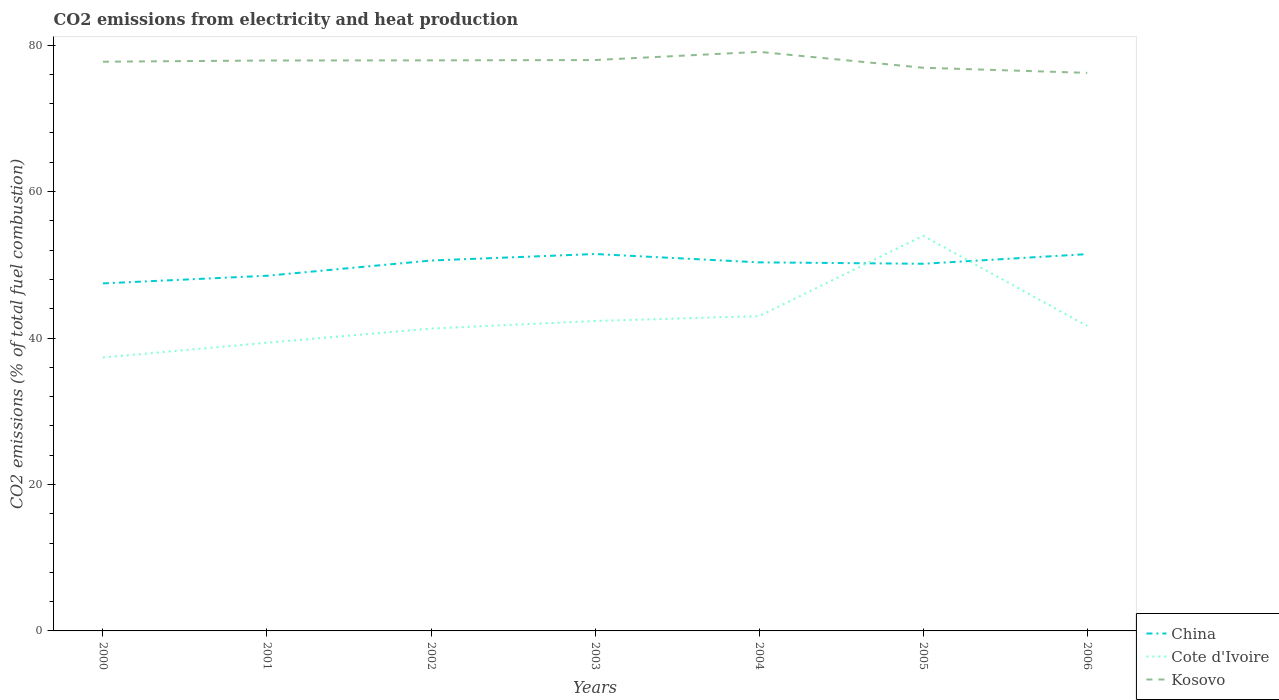Does the line corresponding to Kosovo intersect with the line corresponding to China?
Keep it short and to the point. No. Across all years, what is the maximum amount of CO2 emitted in Kosovo?
Your response must be concise. 76.21. What is the total amount of CO2 emitted in China in the graph?
Make the answer very short. -1.64. What is the difference between the highest and the second highest amount of CO2 emitted in Kosovo?
Your response must be concise. 2.87. What is the difference between the highest and the lowest amount of CO2 emitted in Cote d'Ivoire?
Offer a terse response. 2. How many lines are there?
Offer a very short reply. 3. What is the difference between two consecutive major ticks on the Y-axis?
Provide a succinct answer. 20. Does the graph contain any zero values?
Your answer should be compact. No. Does the graph contain grids?
Your response must be concise. No. How many legend labels are there?
Keep it short and to the point. 3. How are the legend labels stacked?
Ensure brevity in your answer.  Vertical. What is the title of the graph?
Your answer should be compact. CO2 emissions from electricity and heat production. What is the label or title of the Y-axis?
Keep it short and to the point. CO2 emissions (% of total fuel combustion). What is the CO2 emissions (% of total fuel combustion) in China in 2000?
Keep it short and to the point. 47.46. What is the CO2 emissions (% of total fuel combustion) of Cote d'Ivoire in 2000?
Give a very brief answer. 37.34. What is the CO2 emissions (% of total fuel combustion) of Kosovo in 2000?
Offer a terse response. 77.73. What is the CO2 emissions (% of total fuel combustion) of China in 2001?
Your answer should be very brief. 48.5. What is the CO2 emissions (% of total fuel combustion) in Cote d'Ivoire in 2001?
Your answer should be very brief. 39.36. What is the CO2 emissions (% of total fuel combustion) in Kosovo in 2001?
Keep it short and to the point. 77.9. What is the CO2 emissions (% of total fuel combustion) in China in 2002?
Your answer should be very brief. 50.58. What is the CO2 emissions (% of total fuel combustion) in Cote d'Ivoire in 2002?
Provide a succinct answer. 41.29. What is the CO2 emissions (% of total fuel combustion) in Kosovo in 2002?
Keep it short and to the point. 77.92. What is the CO2 emissions (% of total fuel combustion) of China in 2003?
Ensure brevity in your answer.  51.47. What is the CO2 emissions (% of total fuel combustion) in Cote d'Ivoire in 2003?
Keep it short and to the point. 42.33. What is the CO2 emissions (% of total fuel combustion) of Kosovo in 2003?
Your answer should be compact. 77.96. What is the CO2 emissions (% of total fuel combustion) in China in 2004?
Offer a terse response. 50.33. What is the CO2 emissions (% of total fuel combustion) of Cote d'Ivoire in 2004?
Provide a succinct answer. 42.99. What is the CO2 emissions (% of total fuel combustion) of Kosovo in 2004?
Your answer should be compact. 79.08. What is the CO2 emissions (% of total fuel combustion) of China in 2005?
Offer a terse response. 50.14. What is the CO2 emissions (% of total fuel combustion) of Cote d'Ivoire in 2005?
Ensure brevity in your answer.  53.97. What is the CO2 emissions (% of total fuel combustion) in Kosovo in 2005?
Your answer should be very brief. 76.91. What is the CO2 emissions (% of total fuel combustion) of China in 2006?
Offer a very short reply. 51.46. What is the CO2 emissions (% of total fuel combustion) in Cote d'Ivoire in 2006?
Give a very brief answer. 41.64. What is the CO2 emissions (% of total fuel combustion) in Kosovo in 2006?
Ensure brevity in your answer.  76.21. Across all years, what is the maximum CO2 emissions (% of total fuel combustion) of China?
Your response must be concise. 51.47. Across all years, what is the maximum CO2 emissions (% of total fuel combustion) in Cote d'Ivoire?
Offer a very short reply. 53.97. Across all years, what is the maximum CO2 emissions (% of total fuel combustion) in Kosovo?
Keep it short and to the point. 79.08. Across all years, what is the minimum CO2 emissions (% of total fuel combustion) in China?
Provide a short and direct response. 47.46. Across all years, what is the minimum CO2 emissions (% of total fuel combustion) of Cote d'Ivoire?
Your answer should be very brief. 37.34. Across all years, what is the minimum CO2 emissions (% of total fuel combustion) in Kosovo?
Give a very brief answer. 76.21. What is the total CO2 emissions (% of total fuel combustion) in China in the graph?
Your response must be concise. 349.95. What is the total CO2 emissions (% of total fuel combustion) in Cote d'Ivoire in the graph?
Your answer should be compact. 298.91. What is the total CO2 emissions (% of total fuel combustion) in Kosovo in the graph?
Offer a very short reply. 543.72. What is the difference between the CO2 emissions (% of total fuel combustion) in China in 2000 and that in 2001?
Keep it short and to the point. -1.04. What is the difference between the CO2 emissions (% of total fuel combustion) of Cote d'Ivoire in 2000 and that in 2001?
Keep it short and to the point. -2.02. What is the difference between the CO2 emissions (% of total fuel combustion) of Kosovo in 2000 and that in 2001?
Make the answer very short. -0.17. What is the difference between the CO2 emissions (% of total fuel combustion) in China in 2000 and that in 2002?
Provide a short and direct response. -3.12. What is the difference between the CO2 emissions (% of total fuel combustion) of Cote d'Ivoire in 2000 and that in 2002?
Provide a short and direct response. -3.95. What is the difference between the CO2 emissions (% of total fuel combustion) in Kosovo in 2000 and that in 2002?
Offer a very short reply. -0.18. What is the difference between the CO2 emissions (% of total fuel combustion) of China in 2000 and that in 2003?
Keep it short and to the point. -4.01. What is the difference between the CO2 emissions (% of total fuel combustion) of Cote d'Ivoire in 2000 and that in 2003?
Ensure brevity in your answer.  -4.99. What is the difference between the CO2 emissions (% of total fuel combustion) in Kosovo in 2000 and that in 2003?
Keep it short and to the point. -0.23. What is the difference between the CO2 emissions (% of total fuel combustion) of China in 2000 and that in 2004?
Offer a very short reply. -2.87. What is the difference between the CO2 emissions (% of total fuel combustion) in Cote d'Ivoire in 2000 and that in 2004?
Your answer should be very brief. -5.65. What is the difference between the CO2 emissions (% of total fuel combustion) in Kosovo in 2000 and that in 2004?
Provide a succinct answer. -1.35. What is the difference between the CO2 emissions (% of total fuel combustion) in China in 2000 and that in 2005?
Your answer should be very brief. -2.68. What is the difference between the CO2 emissions (% of total fuel combustion) in Cote d'Ivoire in 2000 and that in 2005?
Keep it short and to the point. -16.62. What is the difference between the CO2 emissions (% of total fuel combustion) of Kosovo in 2000 and that in 2005?
Your answer should be compact. 0.82. What is the difference between the CO2 emissions (% of total fuel combustion) in China in 2000 and that in 2006?
Your response must be concise. -4. What is the difference between the CO2 emissions (% of total fuel combustion) in Cote d'Ivoire in 2000 and that in 2006?
Your answer should be compact. -4.3. What is the difference between the CO2 emissions (% of total fuel combustion) of Kosovo in 2000 and that in 2006?
Your answer should be compact. 1.52. What is the difference between the CO2 emissions (% of total fuel combustion) in China in 2001 and that in 2002?
Provide a short and direct response. -2.08. What is the difference between the CO2 emissions (% of total fuel combustion) in Cote d'Ivoire in 2001 and that in 2002?
Offer a very short reply. -1.93. What is the difference between the CO2 emissions (% of total fuel combustion) of Kosovo in 2001 and that in 2002?
Provide a short and direct response. -0.02. What is the difference between the CO2 emissions (% of total fuel combustion) of China in 2001 and that in 2003?
Your answer should be compact. -2.97. What is the difference between the CO2 emissions (% of total fuel combustion) in Cote d'Ivoire in 2001 and that in 2003?
Offer a terse response. -2.97. What is the difference between the CO2 emissions (% of total fuel combustion) in Kosovo in 2001 and that in 2003?
Keep it short and to the point. -0.06. What is the difference between the CO2 emissions (% of total fuel combustion) of China in 2001 and that in 2004?
Offer a very short reply. -1.83. What is the difference between the CO2 emissions (% of total fuel combustion) of Cote d'Ivoire in 2001 and that in 2004?
Make the answer very short. -3.63. What is the difference between the CO2 emissions (% of total fuel combustion) of Kosovo in 2001 and that in 2004?
Offer a very short reply. -1.18. What is the difference between the CO2 emissions (% of total fuel combustion) of China in 2001 and that in 2005?
Keep it short and to the point. -1.64. What is the difference between the CO2 emissions (% of total fuel combustion) of Cote d'Ivoire in 2001 and that in 2005?
Your answer should be compact. -14.61. What is the difference between the CO2 emissions (% of total fuel combustion) in Kosovo in 2001 and that in 2005?
Provide a short and direct response. 0.99. What is the difference between the CO2 emissions (% of total fuel combustion) in China in 2001 and that in 2006?
Give a very brief answer. -2.95. What is the difference between the CO2 emissions (% of total fuel combustion) of Cote d'Ivoire in 2001 and that in 2006?
Make the answer very short. -2.28. What is the difference between the CO2 emissions (% of total fuel combustion) in Kosovo in 2001 and that in 2006?
Provide a succinct answer. 1.69. What is the difference between the CO2 emissions (% of total fuel combustion) of China in 2002 and that in 2003?
Offer a very short reply. -0.89. What is the difference between the CO2 emissions (% of total fuel combustion) in Cote d'Ivoire in 2002 and that in 2003?
Give a very brief answer. -1.04. What is the difference between the CO2 emissions (% of total fuel combustion) of Kosovo in 2002 and that in 2003?
Ensure brevity in your answer.  -0.04. What is the difference between the CO2 emissions (% of total fuel combustion) in China in 2002 and that in 2004?
Offer a terse response. 0.25. What is the difference between the CO2 emissions (% of total fuel combustion) of Cote d'Ivoire in 2002 and that in 2004?
Ensure brevity in your answer.  -1.7. What is the difference between the CO2 emissions (% of total fuel combustion) of Kosovo in 2002 and that in 2004?
Your response must be concise. -1.16. What is the difference between the CO2 emissions (% of total fuel combustion) of China in 2002 and that in 2005?
Your response must be concise. 0.44. What is the difference between the CO2 emissions (% of total fuel combustion) of Cote d'Ivoire in 2002 and that in 2005?
Provide a succinct answer. -12.68. What is the difference between the CO2 emissions (% of total fuel combustion) of Kosovo in 2002 and that in 2005?
Provide a short and direct response. 1.01. What is the difference between the CO2 emissions (% of total fuel combustion) in China in 2002 and that in 2006?
Offer a very short reply. -0.88. What is the difference between the CO2 emissions (% of total fuel combustion) of Cote d'Ivoire in 2002 and that in 2006?
Your answer should be compact. -0.35. What is the difference between the CO2 emissions (% of total fuel combustion) of Kosovo in 2002 and that in 2006?
Your answer should be compact. 1.71. What is the difference between the CO2 emissions (% of total fuel combustion) of China in 2003 and that in 2004?
Make the answer very short. 1.14. What is the difference between the CO2 emissions (% of total fuel combustion) in Cote d'Ivoire in 2003 and that in 2004?
Make the answer very short. -0.66. What is the difference between the CO2 emissions (% of total fuel combustion) in Kosovo in 2003 and that in 2004?
Your answer should be compact. -1.12. What is the difference between the CO2 emissions (% of total fuel combustion) of China in 2003 and that in 2005?
Ensure brevity in your answer.  1.33. What is the difference between the CO2 emissions (% of total fuel combustion) of Cote d'Ivoire in 2003 and that in 2005?
Ensure brevity in your answer.  -11.64. What is the difference between the CO2 emissions (% of total fuel combustion) in Kosovo in 2003 and that in 2005?
Give a very brief answer. 1.05. What is the difference between the CO2 emissions (% of total fuel combustion) of China in 2003 and that in 2006?
Keep it short and to the point. 0.01. What is the difference between the CO2 emissions (% of total fuel combustion) in Cote d'Ivoire in 2003 and that in 2006?
Your response must be concise. 0.69. What is the difference between the CO2 emissions (% of total fuel combustion) of Kosovo in 2003 and that in 2006?
Your answer should be very brief. 1.75. What is the difference between the CO2 emissions (% of total fuel combustion) of China in 2004 and that in 2005?
Make the answer very short. 0.19. What is the difference between the CO2 emissions (% of total fuel combustion) of Cote d'Ivoire in 2004 and that in 2005?
Your answer should be compact. -10.98. What is the difference between the CO2 emissions (% of total fuel combustion) in Kosovo in 2004 and that in 2005?
Keep it short and to the point. 2.17. What is the difference between the CO2 emissions (% of total fuel combustion) in China in 2004 and that in 2006?
Offer a very short reply. -1.12. What is the difference between the CO2 emissions (% of total fuel combustion) in Cote d'Ivoire in 2004 and that in 2006?
Provide a succinct answer. 1.35. What is the difference between the CO2 emissions (% of total fuel combustion) of Kosovo in 2004 and that in 2006?
Give a very brief answer. 2.87. What is the difference between the CO2 emissions (% of total fuel combustion) of China in 2005 and that in 2006?
Provide a short and direct response. -1.32. What is the difference between the CO2 emissions (% of total fuel combustion) in Cote d'Ivoire in 2005 and that in 2006?
Keep it short and to the point. 12.33. What is the difference between the CO2 emissions (% of total fuel combustion) of Kosovo in 2005 and that in 2006?
Keep it short and to the point. 0.7. What is the difference between the CO2 emissions (% of total fuel combustion) in China in 2000 and the CO2 emissions (% of total fuel combustion) in Cote d'Ivoire in 2001?
Your answer should be very brief. 8.1. What is the difference between the CO2 emissions (% of total fuel combustion) of China in 2000 and the CO2 emissions (% of total fuel combustion) of Kosovo in 2001?
Your answer should be very brief. -30.44. What is the difference between the CO2 emissions (% of total fuel combustion) of Cote d'Ivoire in 2000 and the CO2 emissions (% of total fuel combustion) of Kosovo in 2001?
Offer a terse response. -40.56. What is the difference between the CO2 emissions (% of total fuel combustion) in China in 2000 and the CO2 emissions (% of total fuel combustion) in Cote d'Ivoire in 2002?
Offer a very short reply. 6.17. What is the difference between the CO2 emissions (% of total fuel combustion) in China in 2000 and the CO2 emissions (% of total fuel combustion) in Kosovo in 2002?
Offer a very short reply. -30.46. What is the difference between the CO2 emissions (% of total fuel combustion) in Cote d'Ivoire in 2000 and the CO2 emissions (% of total fuel combustion) in Kosovo in 2002?
Your answer should be very brief. -40.58. What is the difference between the CO2 emissions (% of total fuel combustion) in China in 2000 and the CO2 emissions (% of total fuel combustion) in Cote d'Ivoire in 2003?
Your response must be concise. 5.13. What is the difference between the CO2 emissions (% of total fuel combustion) of China in 2000 and the CO2 emissions (% of total fuel combustion) of Kosovo in 2003?
Your response must be concise. -30.5. What is the difference between the CO2 emissions (% of total fuel combustion) in Cote d'Ivoire in 2000 and the CO2 emissions (% of total fuel combustion) in Kosovo in 2003?
Provide a succinct answer. -40.62. What is the difference between the CO2 emissions (% of total fuel combustion) of China in 2000 and the CO2 emissions (% of total fuel combustion) of Cote d'Ivoire in 2004?
Ensure brevity in your answer.  4.47. What is the difference between the CO2 emissions (% of total fuel combustion) of China in 2000 and the CO2 emissions (% of total fuel combustion) of Kosovo in 2004?
Offer a very short reply. -31.62. What is the difference between the CO2 emissions (% of total fuel combustion) in Cote d'Ivoire in 2000 and the CO2 emissions (% of total fuel combustion) in Kosovo in 2004?
Keep it short and to the point. -41.74. What is the difference between the CO2 emissions (% of total fuel combustion) of China in 2000 and the CO2 emissions (% of total fuel combustion) of Cote d'Ivoire in 2005?
Your answer should be compact. -6.51. What is the difference between the CO2 emissions (% of total fuel combustion) in China in 2000 and the CO2 emissions (% of total fuel combustion) in Kosovo in 2005?
Your answer should be very brief. -29.45. What is the difference between the CO2 emissions (% of total fuel combustion) of Cote d'Ivoire in 2000 and the CO2 emissions (% of total fuel combustion) of Kosovo in 2005?
Ensure brevity in your answer.  -39.57. What is the difference between the CO2 emissions (% of total fuel combustion) of China in 2000 and the CO2 emissions (% of total fuel combustion) of Cote d'Ivoire in 2006?
Offer a very short reply. 5.82. What is the difference between the CO2 emissions (% of total fuel combustion) of China in 2000 and the CO2 emissions (% of total fuel combustion) of Kosovo in 2006?
Your answer should be compact. -28.75. What is the difference between the CO2 emissions (% of total fuel combustion) of Cote d'Ivoire in 2000 and the CO2 emissions (% of total fuel combustion) of Kosovo in 2006?
Give a very brief answer. -38.87. What is the difference between the CO2 emissions (% of total fuel combustion) in China in 2001 and the CO2 emissions (% of total fuel combustion) in Cote d'Ivoire in 2002?
Offer a very short reply. 7.22. What is the difference between the CO2 emissions (% of total fuel combustion) of China in 2001 and the CO2 emissions (% of total fuel combustion) of Kosovo in 2002?
Your answer should be compact. -29.41. What is the difference between the CO2 emissions (% of total fuel combustion) in Cote d'Ivoire in 2001 and the CO2 emissions (% of total fuel combustion) in Kosovo in 2002?
Ensure brevity in your answer.  -38.56. What is the difference between the CO2 emissions (% of total fuel combustion) in China in 2001 and the CO2 emissions (% of total fuel combustion) in Cote d'Ivoire in 2003?
Keep it short and to the point. 6.17. What is the difference between the CO2 emissions (% of total fuel combustion) in China in 2001 and the CO2 emissions (% of total fuel combustion) in Kosovo in 2003?
Ensure brevity in your answer.  -29.46. What is the difference between the CO2 emissions (% of total fuel combustion) of Cote d'Ivoire in 2001 and the CO2 emissions (% of total fuel combustion) of Kosovo in 2003?
Offer a terse response. -38.6. What is the difference between the CO2 emissions (% of total fuel combustion) of China in 2001 and the CO2 emissions (% of total fuel combustion) of Cote d'Ivoire in 2004?
Give a very brief answer. 5.52. What is the difference between the CO2 emissions (% of total fuel combustion) in China in 2001 and the CO2 emissions (% of total fuel combustion) in Kosovo in 2004?
Offer a terse response. -30.58. What is the difference between the CO2 emissions (% of total fuel combustion) in Cote d'Ivoire in 2001 and the CO2 emissions (% of total fuel combustion) in Kosovo in 2004?
Provide a short and direct response. -39.72. What is the difference between the CO2 emissions (% of total fuel combustion) of China in 2001 and the CO2 emissions (% of total fuel combustion) of Cote d'Ivoire in 2005?
Provide a succinct answer. -5.46. What is the difference between the CO2 emissions (% of total fuel combustion) of China in 2001 and the CO2 emissions (% of total fuel combustion) of Kosovo in 2005?
Provide a short and direct response. -28.41. What is the difference between the CO2 emissions (% of total fuel combustion) in Cote d'Ivoire in 2001 and the CO2 emissions (% of total fuel combustion) in Kosovo in 2005?
Provide a short and direct response. -37.55. What is the difference between the CO2 emissions (% of total fuel combustion) of China in 2001 and the CO2 emissions (% of total fuel combustion) of Cote d'Ivoire in 2006?
Provide a short and direct response. 6.87. What is the difference between the CO2 emissions (% of total fuel combustion) in China in 2001 and the CO2 emissions (% of total fuel combustion) in Kosovo in 2006?
Provide a short and direct response. -27.71. What is the difference between the CO2 emissions (% of total fuel combustion) of Cote d'Ivoire in 2001 and the CO2 emissions (% of total fuel combustion) of Kosovo in 2006?
Provide a succinct answer. -36.85. What is the difference between the CO2 emissions (% of total fuel combustion) in China in 2002 and the CO2 emissions (% of total fuel combustion) in Cote d'Ivoire in 2003?
Your response must be concise. 8.25. What is the difference between the CO2 emissions (% of total fuel combustion) in China in 2002 and the CO2 emissions (% of total fuel combustion) in Kosovo in 2003?
Offer a terse response. -27.38. What is the difference between the CO2 emissions (% of total fuel combustion) in Cote d'Ivoire in 2002 and the CO2 emissions (% of total fuel combustion) in Kosovo in 2003?
Your answer should be compact. -36.67. What is the difference between the CO2 emissions (% of total fuel combustion) in China in 2002 and the CO2 emissions (% of total fuel combustion) in Cote d'Ivoire in 2004?
Give a very brief answer. 7.59. What is the difference between the CO2 emissions (% of total fuel combustion) in China in 2002 and the CO2 emissions (% of total fuel combustion) in Kosovo in 2004?
Offer a very short reply. -28.5. What is the difference between the CO2 emissions (% of total fuel combustion) in Cote d'Ivoire in 2002 and the CO2 emissions (% of total fuel combustion) in Kosovo in 2004?
Offer a terse response. -37.79. What is the difference between the CO2 emissions (% of total fuel combustion) in China in 2002 and the CO2 emissions (% of total fuel combustion) in Cote d'Ivoire in 2005?
Keep it short and to the point. -3.38. What is the difference between the CO2 emissions (% of total fuel combustion) in China in 2002 and the CO2 emissions (% of total fuel combustion) in Kosovo in 2005?
Ensure brevity in your answer.  -26.33. What is the difference between the CO2 emissions (% of total fuel combustion) in Cote d'Ivoire in 2002 and the CO2 emissions (% of total fuel combustion) in Kosovo in 2005?
Offer a very short reply. -35.62. What is the difference between the CO2 emissions (% of total fuel combustion) in China in 2002 and the CO2 emissions (% of total fuel combustion) in Cote d'Ivoire in 2006?
Offer a very short reply. 8.95. What is the difference between the CO2 emissions (% of total fuel combustion) in China in 2002 and the CO2 emissions (% of total fuel combustion) in Kosovo in 2006?
Ensure brevity in your answer.  -25.63. What is the difference between the CO2 emissions (% of total fuel combustion) in Cote d'Ivoire in 2002 and the CO2 emissions (% of total fuel combustion) in Kosovo in 2006?
Ensure brevity in your answer.  -34.92. What is the difference between the CO2 emissions (% of total fuel combustion) of China in 2003 and the CO2 emissions (% of total fuel combustion) of Cote d'Ivoire in 2004?
Your response must be concise. 8.48. What is the difference between the CO2 emissions (% of total fuel combustion) in China in 2003 and the CO2 emissions (% of total fuel combustion) in Kosovo in 2004?
Provide a short and direct response. -27.61. What is the difference between the CO2 emissions (% of total fuel combustion) of Cote d'Ivoire in 2003 and the CO2 emissions (% of total fuel combustion) of Kosovo in 2004?
Offer a terse response. -36.75. What is the difference between the CO2 emissions (% of total fuel combustion) of China in 2003 and the CO2 emissions (% of total fuel combustion) of Cote d'Ivoire in 2005?
Keep it short and to the point. -2.49. What is the difference between the CO2 emissions (% of total fuel combustion) in China in 2003 and the CO2 emissions (% of total fuel combustion) in Kosovo in 2005?
Ensure brevity in your answer.  -25.44. What is the difference between the CO2 emissions (% of total fuel combustion) of Cote d'Ivoire in 2003 and the CO2 emissions (% of total fuel combustion) of Kosovo in 2005?
Make the answer very short. -34.58. What is the difference between the CO2 emissions (% of total fuel combustion) in China in 2003 and the CO2 emissions (% of total fuel combustion) in Cote d'Ivoire in 2006?
Offer a terse response. 9.83. What is the difference between the CO2 emissions (% of total fuel combustion) in China in 2003 and the CO2 emissions (% of total fuel combustion) in Kosovo in 2006?
Your response must be concise. -24.74. What is the difference between the CO2 emissions (% of total fuel combustion) of Cote d'Ivoire in 2003 and the CO2 emissions (% of total fuel combustion) of Kosovo in 2006?
Your answer should be compact. -33.88. What is the difference between the CO2 emissions (% of total fuel combustion) in China in 2004 and the CO2 emissions (% of total fuel combustion) in Cote d'Ivoire in 2005?
Provide a short and direct response. -3.63. What is the difference between the CO2 emissions (% of total fuel combustion) of China in 2004 and the CO2 emissions (% of total fuel combustion) of Kosovo in 2005?
Your response must be concise. -26.58. What is the difference between the CO2 emissions (% of total fuel combustion) of Cote d'Ivoire in 2004 and the CO2 emissions (% of total fuel combustion) of Kosovo in 2005?
Your answer should be compact. -33.92. What is the difference between the CO2 emissions (% of total fuel combustion) in China in 2004 and the CO2 emissions (% of total fuel combustion) in Cote d'Ivoire in 2006?
Give a very brief answer. 8.7. What is the difference between the CO2 emissions (% of total fuel combustion) of China in 2004 and the CO2 emissions (% of total fuel combustion) of Kosovo in 2006?
Keep it short and to the point. -25.88. What is the difference between the CO2 emissions (% of total fuel combustion) of Cote d'Ivoire in 2004 and the CO2 emissions (% of total fuel combustion) of Kosovo in 2006?
Offer a terse response. -33.22. What is the difference between the CO2 emissions (% of total fuel combustion) of China in 2005 and the CO2 emissions (% of total fuel combustion) of Cote d'Ivoire in 2006?
Your answer should be compact. 8.5. What is the difference between the CO2 emissions (% of total fuel combustion) in China in 2005 and the CO2 emissions (% of total fuel combustion) in Kosovo in 2006?
Offer a terse response. -26.07. What is the difference between the CO2 emissions (% of total fuel combustion) in Cote d'Ivoire in 2005 and the CO2 emissions (% of total fuel combustion) in Kosovo in 2006?
Offer a terse response. -22.25. What is the average CO2 emissions (% of total fuel combustion) in China per year?
Your answer should be very brief. 49.99. What is the average CO2 emissions (% of total fuel combustion) of Cote d'Ivoire per year?
Ensure brevity in your answer.  42.7. What is the average CO2 emissions (% of total fuel combustion) in Kosovo per year?
Your answer should be compact. 77.67. In the year 2000, what is the difference between the CO2 emissions (% of total fuel combustion) in China and CO2 emissions (% of total fuel combustion) in Cote d'Ivoire?
Offer a very short reply. 10.12. In the year 2000, what is the difference between the CO2 emissions (% of total fuel combustion) of China and CO2 emissions (% of total fuel combustion) of Kosovo?
Offer a terse response. -30.27. In the year 2000, what is the difference between the CO2 emissions (% of total fuel combustion) in Cote d'Ivoire and CO2 emissions (% of total fuel combustion) in Kosovo?
Make the answer very short. -40.39. In the year 2001, what is the difference between the CO2 emissions (% of total fuel combustion) of China and CO2 emissions (% of total fuel combustion) of Cote d'Ivoire?
Provide a succinct answer. 9.14. In the year 2001, what is the difference between the CO2 emissions (% of total fuel combustion) of China and CO2 emissions (% of total fuel combustion) of Kosovo?
Your response must be concise. -29.4. In the year 2001, what is the difference between the CO2 emissions (% of total fuel combustion) of Cote d'Ivoire and CO2 emissions (% of total fuel combustion) of Kosovo?
Offer a terse response. -38.54. In the year 2002, what is the difference between the CO2 emissions (% of total fuel combustion) of China and CO2 emissions (% of total fuel combustion) of Cote d'Ivoire?
Offer a very short reply. 9.29. In the year 2002, what is the difference between the CO2 emissions (% of total fuel combustion) in China and CO2 emissions (% of total fuel combustion) in Kosovo?
Your answer should be compact. -27.34. In the year 2002, what is the difference between the CO2 emissions (% of total fuel combustion) in Cote d'Ivoire and CO2 emissions (% of total fuel combustion) in Kosovo?
Give a very brief answer. -36.63. In the year 2003, what is the difference between the CO2 emissions (% of total fuel combustion) in China and CO2 emissions (% of total fuel combustion) in Cote d'Ivoire?
Your response must be concise. 9.14. In the year 2003, what is the difference between the CO2 emissions (% of total fuel combustion) of China and CO2 emissions (% of total fuel combustion) of Kosovo?
Provide a short and direct response. -26.49. In the year 2003, what is the difference between the CO2 emissions (% of total fuel combustion) of Cote d'Ivoire and CO2 emissions (% of total fuel combustion) of Kosovo?
Provide a succinct answer. -35.63. In the year 2004, what is the difference between the CO2 emissions (% of total fuel combustion) of China and CO2 emissions (% of total fuel combustion) of Cote d'Ivoire?
Your answer should be compact. 7.34. In the year 2004, what is the difference between the CO2 emissions (% of total fuel combustion) in China and CO2 emissions (% of total fuel combustion) in Kosovo?
Your response must be concise. -28.75. In the year 2004, what is the difference between the CO2 emissions (% of total fuel combustion) of Cote d'Ivoire and CO2 emissions (% of total fuel combustion) of Kosovo?
Ensure brevity in your answer.  -36.09. In the year 2005, what is the difference between the CO2 emissions (% of total fuel combustion) in China and CO2 emissions (% of total fuel combustion) in Cote d'Ivoire?
Offer a terse response. -3.83. In the year 2005, what is the difference between the CO2 emissions (% of total fuel combustion) of China and CO2 emissions (% of total fuel combustion) of Kosovo?
Offer a very short reply. -26.77. In the year 2005, what is the difference between the CO2 emissions (% of total fuel combustion) in Cote d'Ivoire and CO2 emissions (% of total fuel combustion) in Kosovo?
Make the answer very short. -22.95. In the year 2006, what is the difference between the CO2 emissions (% of total fuel combustion) of China and CO2 emissions (% of total fuel combustion) of Cote d'Ivoire?
Offer a terse response. 9.82. In the year 2006, what is the difference between the CO2 emissions (% of total fuel combustion) in China and CO2 emissions (% of total fuel combustion) in Kosovo?
Offer a terse response. -24.75. In the year 2006, what is the difference between the CO2 emissions (% of total fuel combustion) of Cote d'Ivoire and CO2 emissions (% of total fuel combustion) of Kosovo?
Make the answer very short. -34.58. What is the ratio of the CO2 emissions (% of total fuel combustion) in China in 2000 to that in 2001?
Offer a terse response. 0.98. What is the ratio of the CO2 emissions (% of total fuel combustion) of Cote d'Ivoire in 2000 to that in 2001?
Your answer should be very brief. 0.95. What is the ratio of the CO2 emissions (% of total fuel combustion) of China in 2000 to that in 2002?
Provide a short and direct response. 0.94. What is the ratio of the CO2 emissions (% of total fuel combustion) of Cote d'Ivoire in 2000 to that in 2002?
Ensure brevity in your answer.  0.9. What is the ratio of the CO2 emissions (% of total fuel combustion) in Kosovo in 2000 to that in 2002?
Make the answer very short. 1. What is the ratio of the CO2 emissions (% of total fuel combustion) of China in 2000 to that in 2003?
Your response must be concise. 0.92. What is the ratio of the CO2 emissions (% of total fuel combustion) of Cote d'Ivoire in 2000 to that in 2003?
Provide a succinct answer. 0.88. What is the ratio of the CO2 emissions (% of total fuel combustion) in China in 2000 to that in 2004?
Give a very brief answer. 0.94. What is the ratio of the CO2 emissions (% of total fuel combustion) in Cote d'Ivoire in 2000 to that in 2004?
Offer a terse response. 0.87. What is the ratio of the CO2 emissions (% of total fuel combustion) in Kosovo in 2000 to that in 2004?
Offer a very short reply. 0.98. What is the ratio of the CO2 emissions (% of total fuel combustion) of China in 2000 to that in 2005?
Ensure brevity in your answer.  0.95. What is the ratio of the CO2 emissions (% of total fuel combustion) of Cote d'Ivoire in 2000 to that in 2005?
Provide a short and direct response. 0.69. What is the ratio of the CO2 emissions (% of total fuel combustion) in Kosovo in 2000 to that in 2005?
Your answer should be very brief. 1.01. What is the ratio of the CO2 emissions (% of total fuel combustion) in China in 2000 to that in 2006?
Make the answer very short. 0.92. What is the ratio of the CO2 emissions (% of total fuel combustion) of Cote d'Ivoire in 2000 to that in 2006?
Keep it short and to the point. 0.9. What is the ratio of the CO2 emissions (% of total fuel combustion) in China in 2001 to that in 2002?
Provide a succinct answer. 0.96. What is the ratio of the CO2 emissions (% of total fuel combustion) of Cote d'Ivoire in 2001 to that in 2002?
Provide a short and direct response. 0.95. What is the ratio of the CO2 emissions (% of total fuel combustion) in China in 2001 to that in 2003?
Your answer should be compact. 0.94. What is the ratio of the CO2 emissions (% of total fuel combustion) of Cote d'Ivoire in 2001 to that in 2003?
Your response must be concise. 0.93. What is the ratio of the CO2 emissions (% of total fuel combustion) of Kosovo in 2001 to that in 2003?
Provide a succinct answer. 1. What is the ratio of the CO2 emissions (% of total fuel combustion) of China in 2001 to that in 2004?
Provide a succinct answer. 0.96. What is the ratio of the CO2 emissions (% of total fuel combustion) in Cote d'Ivoire in 2001 to that in 2004?
Offer a terse response. 0.92. What is the ratio of the CO2 emissions (% of total fuel combustion) in Kosovo in 2001 to that in 2004?
Ensure brevity in your answer.  0.99. What is the ratio of the CO2 emissions (% of total fuel combustion) of China in 2001 to that in 2005?
Your response must be concise. 0.97. What is the ratio of the CO2 emissions (% of total fuel combustion) of Cote d'Ivoire in 2001 to that in 2005?
Make the answer very short. 0.73. What is the ratio of the CO2 emissions (% of total fuel combustion) of Kosovo in 2001 to that in 2005?
Your answer should be very brief. 1.01. What is the ratio of the CO2 emissions (% of total fuel combustion) of China in 2001 to that in 2006?
Keep it short and to the point. 0.94. What is the ratio of the CO2 emissions (% of total fuel combustion) in Cote d'Ivoire in 2001 to that in 2006?
Your response must be concise. 0.95. What is the ratio of the CO2 emissions (% of total fuel combustion) in Kosovo in 2001 to that in 2006?
Provide a short and direct response. 1.02. What is the ratio of the CO2 emissions (% of total fuel combustion) of China in 2002 to that in 2003?
Provide a short and direct response. 0.98. What is the ratio of the CO2 emissions (% of total fuel combustion) of Cote d'Ivoire in 2002 to that in 2003?
Offer a terse response. 0.98. What is the ratio of the CO2 emissions (% of total fuel combustion) of Kosovo in 2002 to that in 2003?
Your answer should be compact. 1. What is the ratio of the CO2 emissions (% of total fuel combustion) in China in 2002 to that in 2004?
Ensure brevity in your answer.  1. What is the ratio of the CO2 emissions (% of total fuel combustion) in Cote d'Ivoire in 2002 to that in 2004?
Provide a short and direct response. 0.96. What is the ratio of the CO2 emissions (% of total fuel combustion) in Kosovo in 2002 to that in 2004?
Make the answer very short. 0.99. What is the ratio of the CO2 emissions (% of total fuel combustion) of China in 2002 to that in 2005?
Offer a terse response. 1.01. What is the ratio of the CO2 emissions (% of total fuel combustion) in Cote d'Ivoire in 2002 to that in 2005?
Offer a terse response. 0.77. What is the ratio of the CO2 emissions (% of total fuel combustion) of Kosovo in 2002 to that in 2005?
Provide a succinct answer. 1.01. What is the ratio of the CO2 emissions (% of total fuel combustion) of China in 2002 to that in 2006?
Your answer should be very brief. 0.98. What is the ratio of the CO2 emissions (% of total fuel combustion) of Cote d'Ivoire in 2002 to that in 2006?
Make the answer very short. 0.99. What is the ratio of the CO2 emissions (% of total fuel combustion) of Kosovo in 2002 to that in 2006?
Keep it short and to the point. 1.02. What is the ratio of the CO2 emissions (% of total fuel combustion) of China in 2003 to that in 2004?
Make the answer very short. 1.02. What is the ratio of the CO2 emissions (% of total fuel combustion) in Cote d'Ivoire in 2003 to that in 2004?
Give a very brief answer. 0.98. What is the ratio of the CO2 emissions (% of total fuel combustion) of Kosovo in 2003 to that in 2004?
Provide a succinct answer. 0.99. What is the ratio of the CO2 emissions (% of total fuel combustion) of China in 2003 to that in 2005?
Your answer should be very brief. 1.03. What is the ratio of the CO2 emissions (% of total fuel combustion) in Cote d'Ivoire in 2003 to that in 2005?
Keep it short and to the point. 0.78. What is the ratio of the CO2 emissions (% of total fuel combustion) of Kosovo in 2003 to that in 2005?
Keep it short and to the point. 1.01. What is the ratio of the CO2 emissions (% of total fuel combustion) in China in 2003 to that in 2006?
Offer a terse response. 1. What is the ratio of the CO2 emissions (% of total fuel combustion) of Cote d'Ivoire in 2003 to that in 2006?
Offer a terse response. 1.02. What is the ratio of the CO2 emissions (% of total fuel combustion) in Kosovo in 2003 to that in 2006?
Your response must be concise. 1.02. What is the ratio of the CO2 emissions (% of total fuel combustion) of Cote d'Ivoire in 2004 to that in 2005?
Offer a terse response. 0.8. What is the ratio of the CO2 emissions (% of total fuel combustion) of Kosovo in 2004 to that in 2005?
Your answer should be very brief. 1.03. What is the ratio of the CO2 emissions (% of total fuel combustion) in China in 2004 to that in 2006?
Offer a terse response. 0.98. What is the ratio of the CO2 emissions (% of total fuel combustion) in Cote d'Ivoire in 2004 to that in 2006?
Provide a succinct answer. 1.03. What is the ratio of the CO2 emissions (% of total fuel combustion) of Kosovo in 2004 to that in 2006?
Keep it short and to the point. 1.04. What is the ratio of the CO2 emissions (% of total fuel combustion) in China in 2005 to that in 2006?
Your response must be concise. 0.97. What is the ratio of the CO2 emissions (% of total fuel combustion) in Cote d'Ivoire in 2005 to that in 2006?
Your response must be concise. 1.3. What is the ratio of the CO2 emissions (% of total fuel combustion) of Kosovo in 2005 to that in 2006?
Provide a short and direct response. 1.01. What is the difference between the highest and the second highest CO2 emissions (% of total fuel combustion) of China?
Provide a short and direct response. 0.01. What is the difference between the highest and the second highest CO2 emissions (% of total fuel combustion) of Cote d'Ivoire?
Provide a succinct answer. 10.98. What is the difference between the highest and the second highest CO2 emissions (% of total fuel combustion) in Kosovo?
Your answer should be compact. 1.12. What is the difference between the highest and the lowest CO2 emissions (% of total fuel combustion) in China?
Give a very brief answer. 4.01. What is the difference between the highest and the lowest CO2 emissions (% of total fuel combustion) in Cote d'Ivoire?
Provide a succinct answer. 16.62. What is the difference between the highest and the lowest CO2 emissions (% of total fuel combustion) of Kosovo?
Keep it short and to the point. 2.87. 